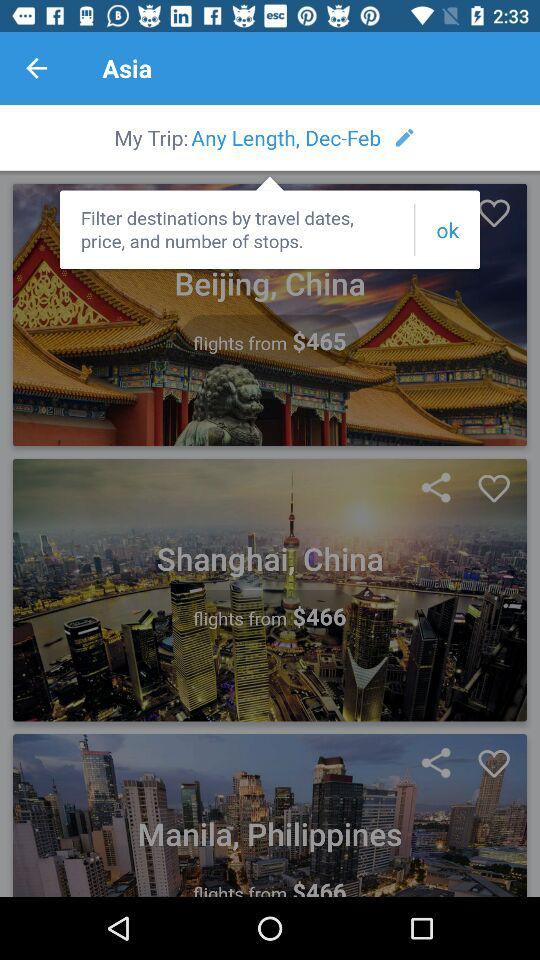What is the price of flight to Beijing, China? The price of flight to Beijing, China is $465. 